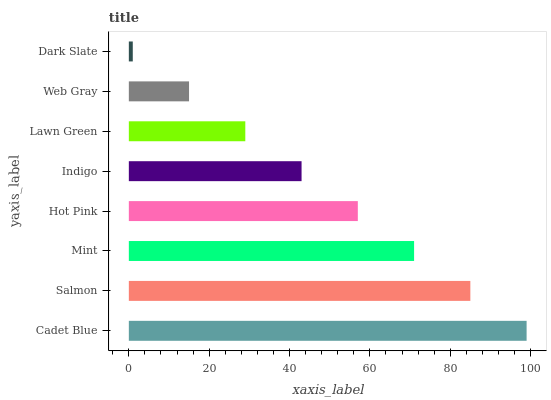Is Dark Slate the minimum?
Answer yes or no. Yes. Is Cadet Blue the maximum?
Answer yes or no. Yes. Is Salmon the minimum?
Answer yes or no. No. Is Salmon the maximum?
Answer yes or no. No. Is Cadet Blue greater than Salmon?
Answer yes or no. Yes. Is Salmon less than Cadet Blue?
Answer yes or no. Yes. Is Salmon greater than Cadet Blue?
Answer yes or no. No. Is Cadet Blue less than Salmon?
Answer yes or no. No. Is Hot Pink the high median?
Answer yes or no. Yes. Is Indigo the low median?
Answer yes or no. Yes. Is Cadet Blue the high median?
Answer yes or no. No. Is Salmon the low median?
Answer yes or no. No. 